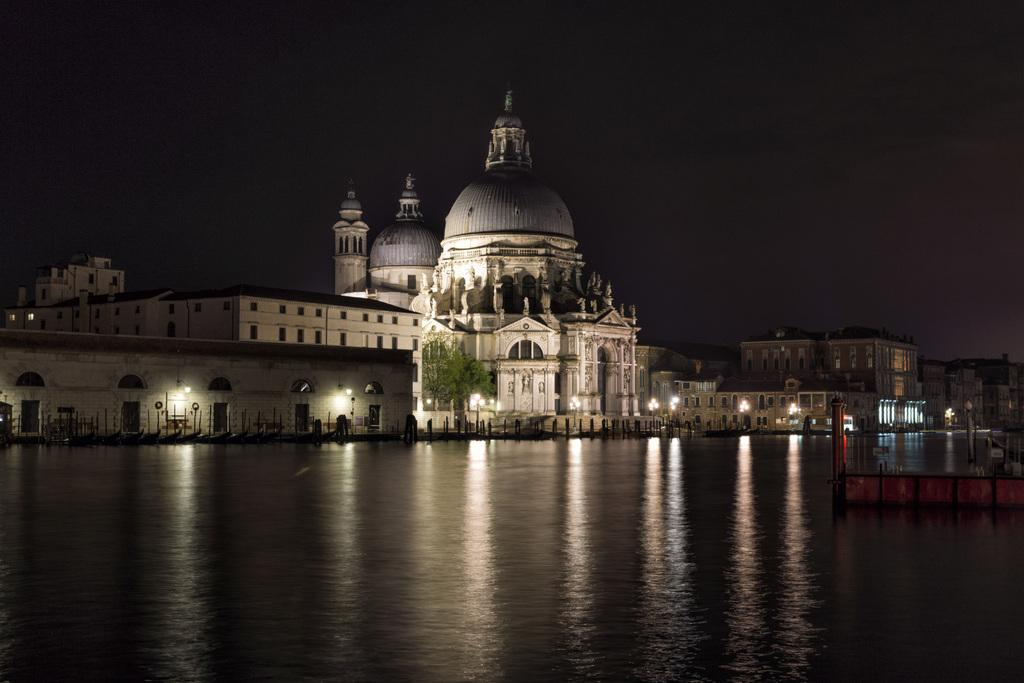What type of structures can be seen in the image? There are buildings in the image. Can you describe the vegetation near a building? There is a tree near a building in the image. What can be seen illuminating the scene in the image? There are lights in the image. What type of objects can be seen in the image? There are rods in the image. What natural element is visible in the image? There is water visible in the image. What type of architectural feature can be seen on the right side of the image? There is an object that looks like a bridge on the right side of the image. What is visible in the background of the image? The sky is visible in the background of the image. Can you tell me how many marbles are scattered on the ground in the image? There are no marbles present in the image. What type of notebook is lying on the bridge in the image? There is no notebook present in the image. 